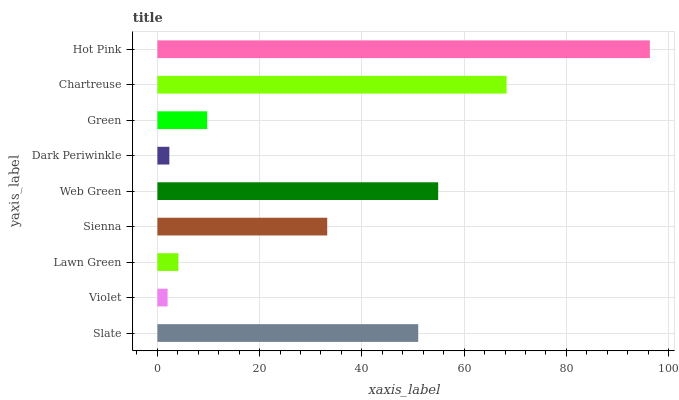Is Violet the minimum?
Answer yes or no. Yes. Is Hot Pink the maximum?
Answer yes or no. Yes. Is Lawn Green the minimum?
Answer yes or no. No. Is Lawn Green the maximum?
Answer yes or no. No. Is Lawn Green greater than Violet?
Answer yes or no. Yes. Is Violet less than Lawn Green?
Answer yes or no. Yes. Is Violet greater than Lawn Green?
Answer yes or no. No. Is Lawn Green less than Violet?
Answer yes or no. No. Is Sienna the high median?
Answer yes or no. Yes. Is Sienna the low median?
Answer yes or no. Yes. Is Violet the high median?
Answer yes or no. No. Is Hot Pink the low median?
Answer yes or no. No. 